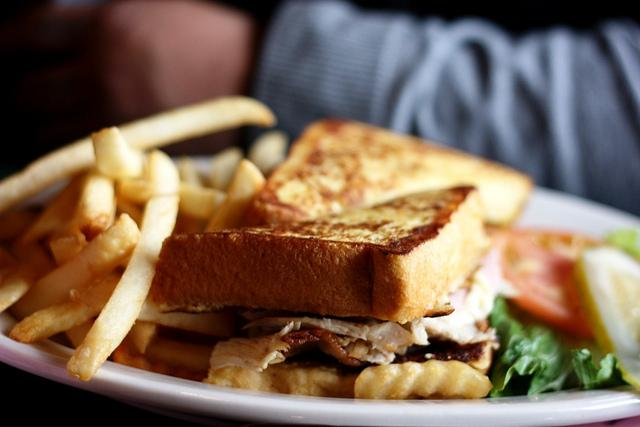What commonly goes on the long light yellow food here?

Choices:
A) soy sauce
B) wasabi
C) ketchup
D) oyster sauce ketchup 